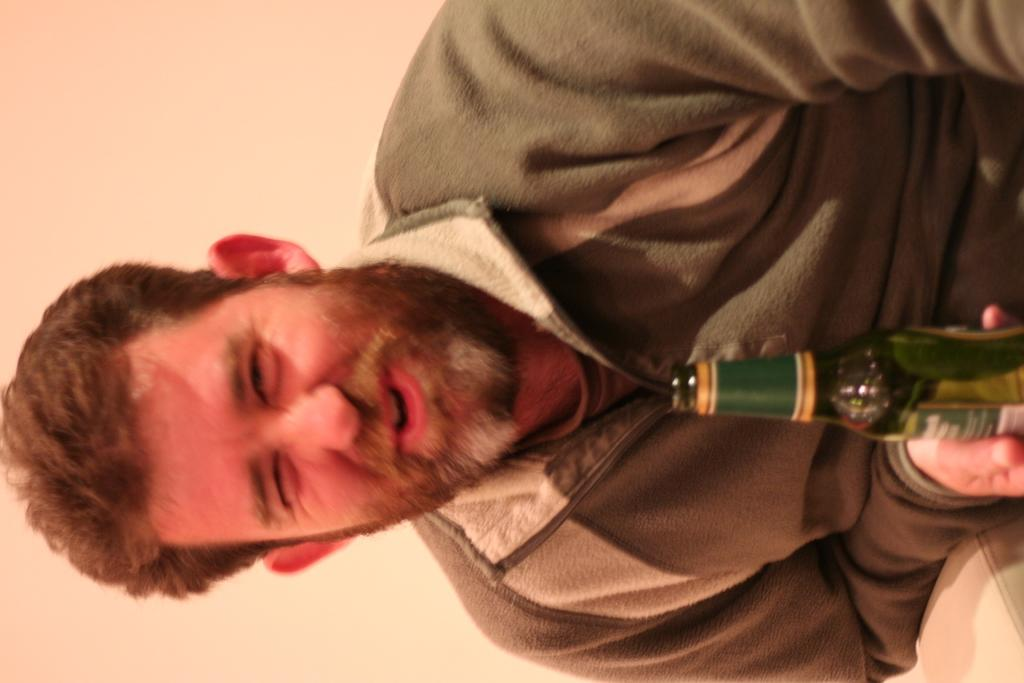Who or what is the main subject in the image? There is a person in the image. What is the person holding in the image? The person is holding a green glass bottle. What can be seen in the background of the image? There is a wall in the background of the image. What type of receipt can be seen in the person's hand in the image? There is no receipt visible in the person's hand or anywhere else in the image. 